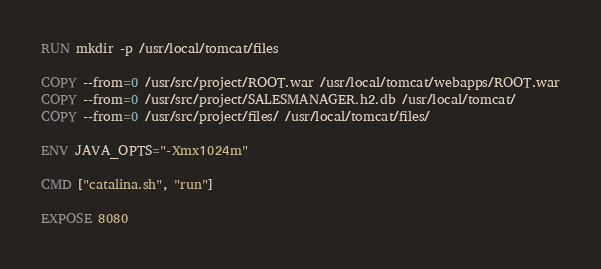Convert code to text. <code><loc_0><loc_0><loc_500><loc_500><_Dockerfile_>RUN mkdir -p /usr/local/tomcat/files

COPY --from=0 /usr/src/project/ROOT.war /usr/local/tomcat/webapps/ROOT.war
COPY --from=0 /usr/src/project/SALESMANAGER.h2.db /usr/local/tomcat/
COPY --from=0 /usr/src/project/files/ /usr/local/tomcat/files/

ENV JAVA_OPTS="-Xmx1024m"

CMD ["catalina.sh", "run"]

EXPOSE 8080</code> 